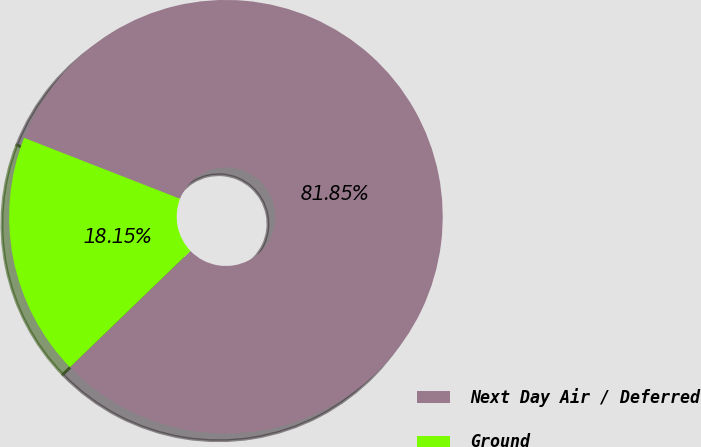<chart> <loc_0><loc_0><loc_500><loc_500><pie_chart><fcel>Next Day Air / Deferred<fcel>Ground<nl><fcel>81.85%<fcel>18.15%<nl></chart> 